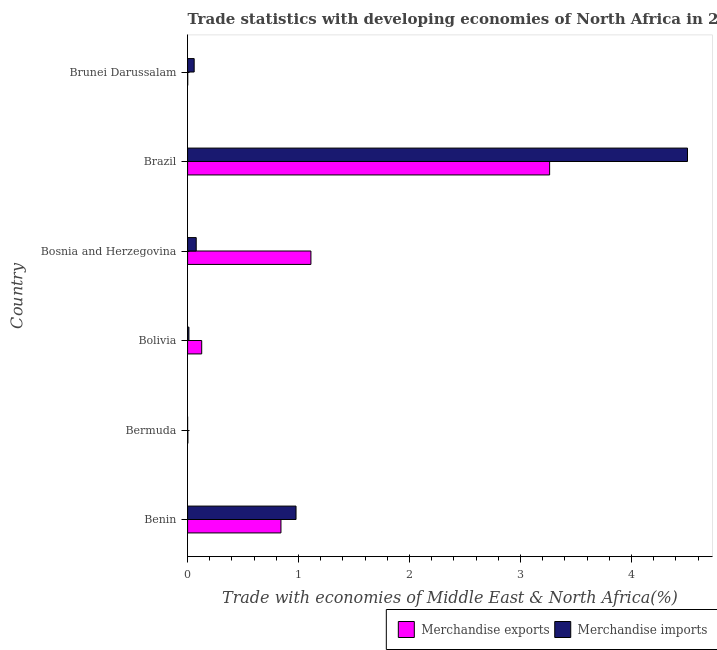How many different coloured bars are there?
Ensure brevity in your answer.  2. How many groups of bars are there?
Give a very brief answer. 6. Are the number of bars per tick equal to the number of legend labels?
Keep it short and to the point. Yes. How many bars are there on the 3rd tick from the top?
Your answer should be very brief. 2. How many bars are there on the 5th tick from the bottom?
Your answer should be very brief. 2. What is the label of the 6th group of bars from the top?
Offer a very short reply. Benin. In how many cases, is the number of bars for a given country not equal to the number of legend labels?
Your response must be concise. 0. What is the merchandise imports in Bosnia and Herzegovina?
Offer a very short reply. 0.08. Across all countries, what is the maximum merchandise exports?
Keep it short and to the point. 3.26. Across all countries, what is the minimum merchandise imports?
Your answer should be very brief. 4.991405699987221e-5. In which country was the merchandise imports maximum?
Provide a short and direct response. Brazil. In which country was the merchandise exports minimum?
Offer a terse response. Brunei Darussalam. What is the total merchandise imports in the graph?
Make the answer very short. 5.63. What is the difference between the merchandise imports in Bermuda and that in Brazil?
Provide a short and direct response. -4.5. What is the difference between the merchandise imports in Benin and the merchandise exports in Bolivia?
Provide a succinct answer. 0.85. What is the average merchandise imports per country?
Provide a short and direct response. 0.94. What is the difference between the merchandise exports and merchandise imports in Bosnia and Herzegovina?
Your answer should be compact. 1.03. What is the ratio of the merchandise exports in Bosnia and Herzegovina to that in Brazil?
Your response must be concise. 0.34. Is the merchandise exports in Brazil less than that in Brunei Darussalam?
Ensure brevity in your answer.  No. What is the difference between the highest and the second highest merchandise imports?
Provide a short and direct response. 3.53. What is the difference between the highest and the lowest merchandise exports?
Your answer should be very brief. 3.26. In how many countries, is the merchandise exports greater than the average merchandise exports taken over all countries?
Give a very brief answer. 2. Is the sum of the merchandise exports in Brazil and Brunei Darussalam greater than the maximum merchandise imports across all countries?
Make the answer very short. No. What does the 2nd bar from the top in Brunei Darussalam represents?
Your response must be concise. Merchandise exports. Are all the bars in the graph horizontal?
Provide a short and direct response. Yes. Are the values on the major ticks of X-axis written in scientific E-notation?
Your answer should be very brief. No. What is the title of the graph?
Offer a terse response. Trade statistics with developing economies of North Africa in 2004. What is the label or title of the X-axis?
Provide a succinct answer. Trade with economies of Middle East & North Africa(%). What is the Trade with economies of Middle East & North Africa(%) in Merchandise exports in Benin?
Ensure brevity in your answer.  0.84. What is the Trade with economies of Middle East & North Africa(%) in Merchandise imports in Benin?
Offer a very short reply. 0.98. What is the Trade with economies of Middle East & North Africa(%) of Merchandise exports in Bermuda?
Offer a terse response. 0. What is the Trade with economies of Middle East & North Africa(%) of Merchandise imports in Bermuda?
Make the answer very short. 4.991405699987221e-5. What is the Trade with economies of Middle East & North Africa(%) in Merchandise exports in Bolivia?
Offer a terse response. 0.13. What is the Trade with economies of Middle East & North Africa(%) in Merchandise imports in Bolivia?
Keep it short and to the point. 0.01. What is the Trade with economies of Middle East & North Africa(%) of Merchandise exports in Bosnia and Herzegovina?
Provide a short and direct response. 1.11. What is the Trade with economies of Middle East & North Africa(%) of Merchandise imports in Bosnia and Herzegovina?
Offer a terse response. 0.08. What is the Trade with economies of Middle East & North Africa(%) in Merchandise exports in Brazil?
Your response must be concise. 3.26. What is the Trade with economies of Middle East & North Africa(%) in Merchandise imports in Brazil?
Offer a very short reply. 4.5. What is the Trade with economies of Middle East & North Africa(%) in Merchandise exports in Brunei Darussalam?
Give a very brief answer. 0. What is the Trade with economies of Middle East & North Africa(%) in Merchandise imports in Brunei Darussalam?
Your answer should be compact. 0.06. Across all countries, what is the maximum Trade with economies of Middle East & North Africa(%) of Merchandise exports?
Your answer should be very brief. 3.26. Across all countries, what is the maximum Trade with economies of Middle East & North Africa(%) in Merchandise imports?
Your response must be concise. 4.5. Across all countries, what is the minimum Trade with economies of Middle East & North Africa(%) of Merchandise exports?
Your response must be concise. 0. Across all countries, what is the minimum Trade with economies of Middle East & North Africa(%) in Merchandise imports?
Make the answer very short. 4.991405699987221e-5. What is the total Trade with economies of Middle East & North Africa(%) of Merchandise exports in the graph?
Offer a very short reply. 5.35. What is the total Trade with economies of Middle East & North Africa(%) of Merchandise imports in the graph?
Your response must be concise. 5.63. What is the difference between the Trade with economies of Middle East & North Africa(%) of Merchandise exports in Benin and that in Bermuda?
Your answer should be compact. 0.84. What is the difference between the Trade with economies of Middle East & North Africa(%) of Merchandise imports in Benin and that in Bermuda?
Offer a terse response. 0.98. What is the difference between the Trade with economies of Middle East & North Africa(%) of Merchandise exports in Benin and that in Bolivia?
Make the answer very short. 0.71. What is the difference between the Trade with economies of Middle East & North Africa(%) in Merchandise imports in Benin and that in Bolivia?
Provide a succinct answer. 0.97. What is the difference between the Trade with economies of Middle East & North Africa(%) of Merchandise exports in Benin and that in Bosnia and Herzegovina?
Offer a terse response. -0.27. What is the difference between the Trade with economies of Middle East & North Africa(%) of Merchandise imports in Benin and that in Bosnia and Herzegovina?
Your answer should be compact. 0.9. What is the difference between the Trade with economies of Middle East & North Africa(%) of Merchandise exports in Benin and that in Brazil?
Provide a short and direct response. -2.42. What is the difference between the Trade with economies of Middle East & North Africa(%) of Merchandise imports in Benin and that in Brazil?
Offer a very short reply. -3.53. What is the difference between the Trade with economies of Middle East & North Africa(%) of Merchandise exports in Benin and that in Brunei Darussalam?
Provide a short and direct response. 0.84. What is the difference between the Trade with economies of Middle East & North Africa(%) in Merchandise imports in Benin and that in Brunei Darussalam?
Your answer should be compact. 0.92. What is the difference between the Trade with economies of Middle East & North Africa(%) in Merchandise exports in Bermuda and that in Bolivia?
Make the answer very short. -0.12. What is the difference between the Trade with economies of Middle East & North Africa(%) in Merchandise imports in Bermuda and that in Bolivia?
Your answer should be very brief. -0.01. What is the difference between the Trade with economies of Middle East & North Africa(%) in Merchandise exports in Bermuda and that in Bosnia and Herzegovina?
Give a very brief answer. -1.11. What is the difference between the Trade with economies of Middle East & North Africa(%) of Merchandise imports in Bermuda and that in Bosnia and Herzegovina?
Provide a short and direct response. -0.08. What is the difference between the Trade with economies of Middle East & North Africa(%) in Merchandise exports in Bermuda and that in Brazil?
Provide a succinct answer. -3.26. What is the difference between the Trade with economies of Middle East & North Africa(%) in Merchandise imports in Bermuda and that in Brazil?
Your answer should be compact. -4.5. What is the difference between the Trade with economies of Middle East & North Africa(%) in Merchandise exports in Bermuda and that in Brunei Darussalam?
Make the answer very short. 0. What is the difference between the Trade with economies of Middle East & North Africa(%) of Merchandise imports in Bermuda and that in Brunei Darussalam?
Provide a succinct answer. -0.06. What is the difference between the Trade with economies of Middle East & North Africa(%) of Merchandise exports in Bolivia and that in Bosnia and Herzegovina?
Provide a short and direct response. -0.98. What is the difference between the Trade with economies of Middle East & North Africa(%) in Merchandise imports in Bolivia and that in Bosnia and Herzegovina?
Offer a terse response. -0.07. What is the difference between the Trade with economies of Middle East & North Africa(%) in Merchandise exports in Bolivia and that in Brazil?
Make the answer very short. -3.13. What is the difference between the Trade with economies of Middle East & North Africa(%) of Merchandise imports in Bolivia and that in Brazil?
Offer a very short reply. -4.49. What is the difference between the Trade with economies of Middle East & North Africa(%) in Merchandise exports in Bolivia and that in Brunei Darussalam?
Make the answer very short. 0.13. What is the difference between the Trade with economies of Middle East & North Africa(%) in Merchandise imports in Bolivia and that in Brunei Darussalam?
Keep it short and to the point. -0.05. What is the difference between the Trade with economies of Middle East & North Africa(%) of Merchandise exports in Bosnia and Herzegovina and that in Brazil?
Ensure brevity in your answer.  -2.15. What is the difference between the Trade with economies of Middle East & North Africa(%) of Merchandise imports in Bosnia and Herzegovina and that in Brazil?
Give a very brief answer. -4.43. What is the difference between the Trade with economies of Middle East & North Africa(%) of Merchandise exports in Bosnia and Herzegovina and that in Brunei Darussalam?
Your answer should be compact. 1.11. What is the difference between the Trade with economies of Middle East & North Africa(%) in Merchandise imports in Bosnia and Herzegovina and that in Brunei Darussalam?
Ensure brevity in your answer.  0.02. What is the difference between the Trade with economies of Middle East & North Africa(%) of Merchandise exports in Brazil and that in Brunei Darussalam?
Keep it short and to the point. 3.26. What is the difference between the Trade with economies of Middle East & North Africa(%) in Merchandise imports in Brazil and that in Brunei Darussalam?
Your response must be concise. 4.45. What is the difference between the Trade with economies of Middle East & North Africa(%) in Merchandise exports in Benin and the Trade with economies of Middle East & North Africa(%) in Merchandise imports in Bermuda?
Your response must be concise. 0.84. What is the difference between the Trade with economies of Middle East & North Africa(%) of Merchandise exports in Benin and the Trade with economies of Middle East & North Africa(%) of Merchandise imports in Bolivia?
Your answer should be compact. 0.83. What is the difference between the Trade with economies of Middle East & North Africa(%) in Merchandise exports in Benin and the Trade with economies of Middle East & North Africa(%) in Merchandise imports in Bosnia and Herzegovina?
Provide a succinct answer. 0.76. What is the difference between the Trade with economies of Middle East & North Africa(%) of Merchandise exports in Benin and the Trade with economies of Middle East & North Africa(%) of Merchandise imports in Brazil?
Ensure brevity in your answer.  -3.66. What is the difference between the Trade with economies of Middle East & North Africa(%) in Merchandise exports in Benin and the Trade with economies of Middle East & North Africa(%) in Merchandise imports in Brunei Darussalam?
Your answer should be very brief. 0.78. What is the difference between the Trade with economies of Middle East & North Africa(%) in Merchandise exports in Bermuda and the Trade with economies of Middle East & North Africa(%) in Merchandise imports in Bolivia?
Your response must be concise. -0.01. What is the difference between the Trade with economies of Middle East & North Africa(%) in Merchandise exports in Bermuda and the Trade with economies of Middle East & North Africa(%) in Merchandise imports in Bosnia and Herzegovina?
Provide a short and direct response. -0.08. What is the difference between the Trade with economies of Middle East & North Africa(%) of Merchandise exports in Bermuda and the Trade with economies of Middle East & North Africa(%) of Merchandise imports in Brazil?
Your answer should be compact. -4.5. What is the difference between the Trade with economies of Middle East & North Africa(%) of Merchandise exports in Bermuda and the Trade with economies of Middle East & North Africa(%) of Merchandise imports in Brunei Darussalam?
Offer a terse response. -0.06. What is the difference between the Trade with economies of Middle East & North Africa(%) in Merchandise exports in Bolivia and the Trade with economies of Middle East & North Africa(%) in Merchandise imports in Bosnia and Herzegovina?
Your response must be concise. 0.05. What is the difference between the Trade with economies of Middle East & North Africa(%) in Merchandise exports in Bolivia and the Trade with economies of Middle East & North Africa(%) in Merchandise imports in Brazil?
Offer a terse response. -4.38. What is the difference between the Trade with economies of Middle East & North Africa(%) of Merchandise exports in Bolivia and the Trade with economies of Middle East & North Africa(%) of Merchandise imports in Brunei Darussalam?
Keep it short and to the point. 0.07. What is the difference between the Trade with economies of Middle East & North Africa(%) of Merchandise exports in Bosnia and Herzegovina and the Trade with economies of Middle East & North Africa(%) of Merchandise imports in Brazil?
Ensure brevity in your answer.  -3.39. What is the difference between the Trade with economies of Middle East & North Africa(%) of Merchandise exports in Bosnia and Herzegovina and the Trade with economies of Middle East & North Africa(%) of Merchandise imports in Brunei Darussalam?
Your answer should be very brief. 1.05. What is the difference between the Trade with economies of Middle East & North Africa(%) in Merchandise exports in Brazil and the Trade with economies of Middle East & North Africa(%) in Merchandise imports in Brunei Darussalam?
Your answer should be compact. 3.2. What is the average Trade with economies of Middle East & North Africa(%) in Merchandise exports per country?
Make the answer very short. 0.89. What is the average Trade with economies of Middle East & North Africa(%) in Merchandise imports per country?
Your answer should be very brief. 0.94. What is the difference between the Trade with economies of Middle East & North Africa(%) of Merchandise exports and Trade with economies of Middle East & North Africa(%) of Merchandise imports in Benin?
Provide a succinct answer. -0.14. What is the difference between the Trade with economies of Middle East & North Africa(%) of Merchandise exports and Trade with economies of Middle East & North Africa(%) of Merchandise imports in Bermuda?
Provide a succinct answer. 0. What is the difference between the Trade with economies of Middle East & North Africa(%) in Merchandise exports and Trade with economies of Middle East & North Africa(%) in Merchandise imports in Bolivia?
Your answer should be very brief. 0.12. What is the difference between the Trade with economies of Middle East & North Africa(%) in Merchandise exports and Trade with economies of Middle East & North Africa(%) in Merchandise imports in Bosnia and Herzegovina?
Your answer should be compact. 1.03. What is the difference between the Trade with economies of Middle East & North Africa(%) in Merchandise exports and Trade with economies of Middle East & North Africa(%) in Merchandise imports in Brazil?
Offer a terse response. -1.24. What is the difference between the Trade with economies of Middle East & North Africa(%) of Merchandise exports and Trade with economies of Middle East & North Africa(%) of Merchandise imports in Brunei Darussalam?
Ensure brevity in your answer.  -0.06. What is the ratio of the Trade with economies of Middle East & North Africa(%) of Merchandise exports in Benin to that in Bermuda?
Provide a succinct answer. 341.91. What is the ratio of the Trade with economies of Middle East & North Africa(%) of Merchandise imports in Benin to that in Bermuda?
Provide a short and direct response. 1.96e+04. What is the ratio of the Trade with economies of Middle East & North Africa(%) in Merchandise exports in Benin to that in Bolivia?
Your answer should be very brief. 6.62. What is the ratio of the Trade with economies of Middle East & North Africa(%) of Merchandise imports in Benin to that in Bolivia?
Provide a short and direct response. 82.25. What is the ratio of the Trade with economies of Middle East & North Africa(%) in Merchandise exports in Benin to that in Bosnia and Herzegovina?
Provide a short and direct response. 0.76. What is the ratio of the Trade with economies of Middle East & North Africa(%) in Merchandise imports in Benin to that in Bosnia and Herzegovina?
Your answer should be very brief. 12.57. What is the ratio of the Trade with economies of Middle East & North Africa(%) of Merchandise exports in Benin to that in Brazil?
Your answer should be compact. 0.26. What is the ratio of the Trade with economies of Middle East & North Africa(%) of Merchandise imports in Benin to that in Brazil?
Make the answer very short. 0.22. What is the ratio of the Trade with economies of Middle East & North Africa(%) in Merchandise exports in Benin to that in Brunei Darussalam?
Offer a terse response. 810.15. What is the ratio of the Trade with economies of Middle East & North Africa(%) of Merchandise imports in Benin to that in Brunei Darussalam?
Your answer should be very brief. 16.47. What is the ratio of the Trade with economies of Middle East & North Africa(%) of Merchandise exports in Bermuda to that in Bolivia?
Offer a very short reply. 0.02. What is the ratio of the Trade with economies of Middle East & North Africa(%) in Merchandise imports in Bermuda to that in Bolivia?
Offer a terse response. 0. What is the ratio of the Trade with economies of Middle East & North Africa(%) of Merchandise exports in Bermuda to that in Bosnia and Herzegovina?
Provide a short and direct response. 0. What is the ratio of the Trade with economies of Middle East & North Africa(%) of Merchandise imports in Bermuda to that in Bosnia and Herzegovina?
Make the answer very short. 0. What is the ratio of the Trade with economies of Middle East & North Africa(%) in Merchandise exports in Bermuda to that in Brazil?
Your answer should be compact. 0. What is the ratio of the Trade with economies of Middle East & North Africa(%) in Merchandise exports in Bermuda to that in Brunei Darussalam?
Ensure brevity in your answer.  2.37. What is the ratio of the Trade with economies of Middle East & North Africa(%) of Merchandise imports in Bermuda to that in Brunei Darussalam?
Provide a succinct answer. 0. What is the ratio of the Trade with economies of Middle East & North Africa(%) of Merchandise exports in Bolivia to that in Bosnia and Herzegovina?
Offer a terse response. 0.11. What is the ratio of the Trade with economies of Middle East & North Africa(%) of Merchandise imports in Bolivia to that in Bosnia and Herzegovina?
Offer a very short reply. 0.15. What is the ratio of the Trade with economies of Middle East & North Africa(%) in Merchandise exports in Bolivia to that in Brazil?
Your answer should be compact. 0.04. What is the ratio of the Trade with economies of Middle East & North Africa(%) in Merchandise imports in Bolivia to that in Brazil?
Make the answer very short. 0. What is the ratio of the Trade with economies of Middle East & North Africa(%) in Merchandise exports in Bolivia to that in Brunei Darussalam?
Your response must be concise. 122.36. What is the ratio of the Trade with economies of Middle East & North Africa(%) in Merchandise imports in Bolivia to that in Brunei Darussalam?
Your answer should be compact. 0.2. What is the ratio of the Trade with economies of Middle East & North Africa(%) of Merchandise exports in Bosnia and Herzegovina to that in Brazil?
Your answer should be very brief. 0.34. What is the ratio of the Trade with economies of Middle East & North Africa(%) in Merchandise imports in Bosnia and Herzegovina to that in Brazil?
Your answer should be very brief. 0.02. What is the ratio of the Trade with economies of Middle East & North Africa(%) of Merchandise exports in Bosnia and Herzegovina to that in Brunei Darussalam?
Provide a short and direct response. 1070.23. What is the ratio of the Trade with economies of Middle East & North Africa(%) in Merchandise imports in Bosnia and Herzegovina to that in Brunei Darussalam?
Ensure brevity in your answer.  1.31. What is the ratio of the Trade with economies of Middle East & North Africa(%) in Merchandise exports in Brazil to that in Brunei Darussalam?
Make the answer very short. 3141.47. What is the ratio of the Trade with economies of Middle East & North Africa(%) in Merchandise imports in Brazil to that in Brunei Darussalam?
Offer a very short reply. 75.94. What is the difference between the highest and the second highest Trade with economies of Middle East & North Africa(%) of Merchandise exports?
Ensure brevity in your answer.  2.15. What is the difference between the highest and the second highest Trade with economies of Middle East & North Africa(%) of Merchandise imports?
Make the answer very short. 3.53. What is the difference between the highest and the lowest Trade with economies of Middle East & North Africa(%) of Merchandise exports?
Your answer should be compact. 3.26. What is the difference between the highest and the lowest Trade with economies of Middle East & North Africa(%) of Merchandise imports?
Make the answer very short. 4.5. 